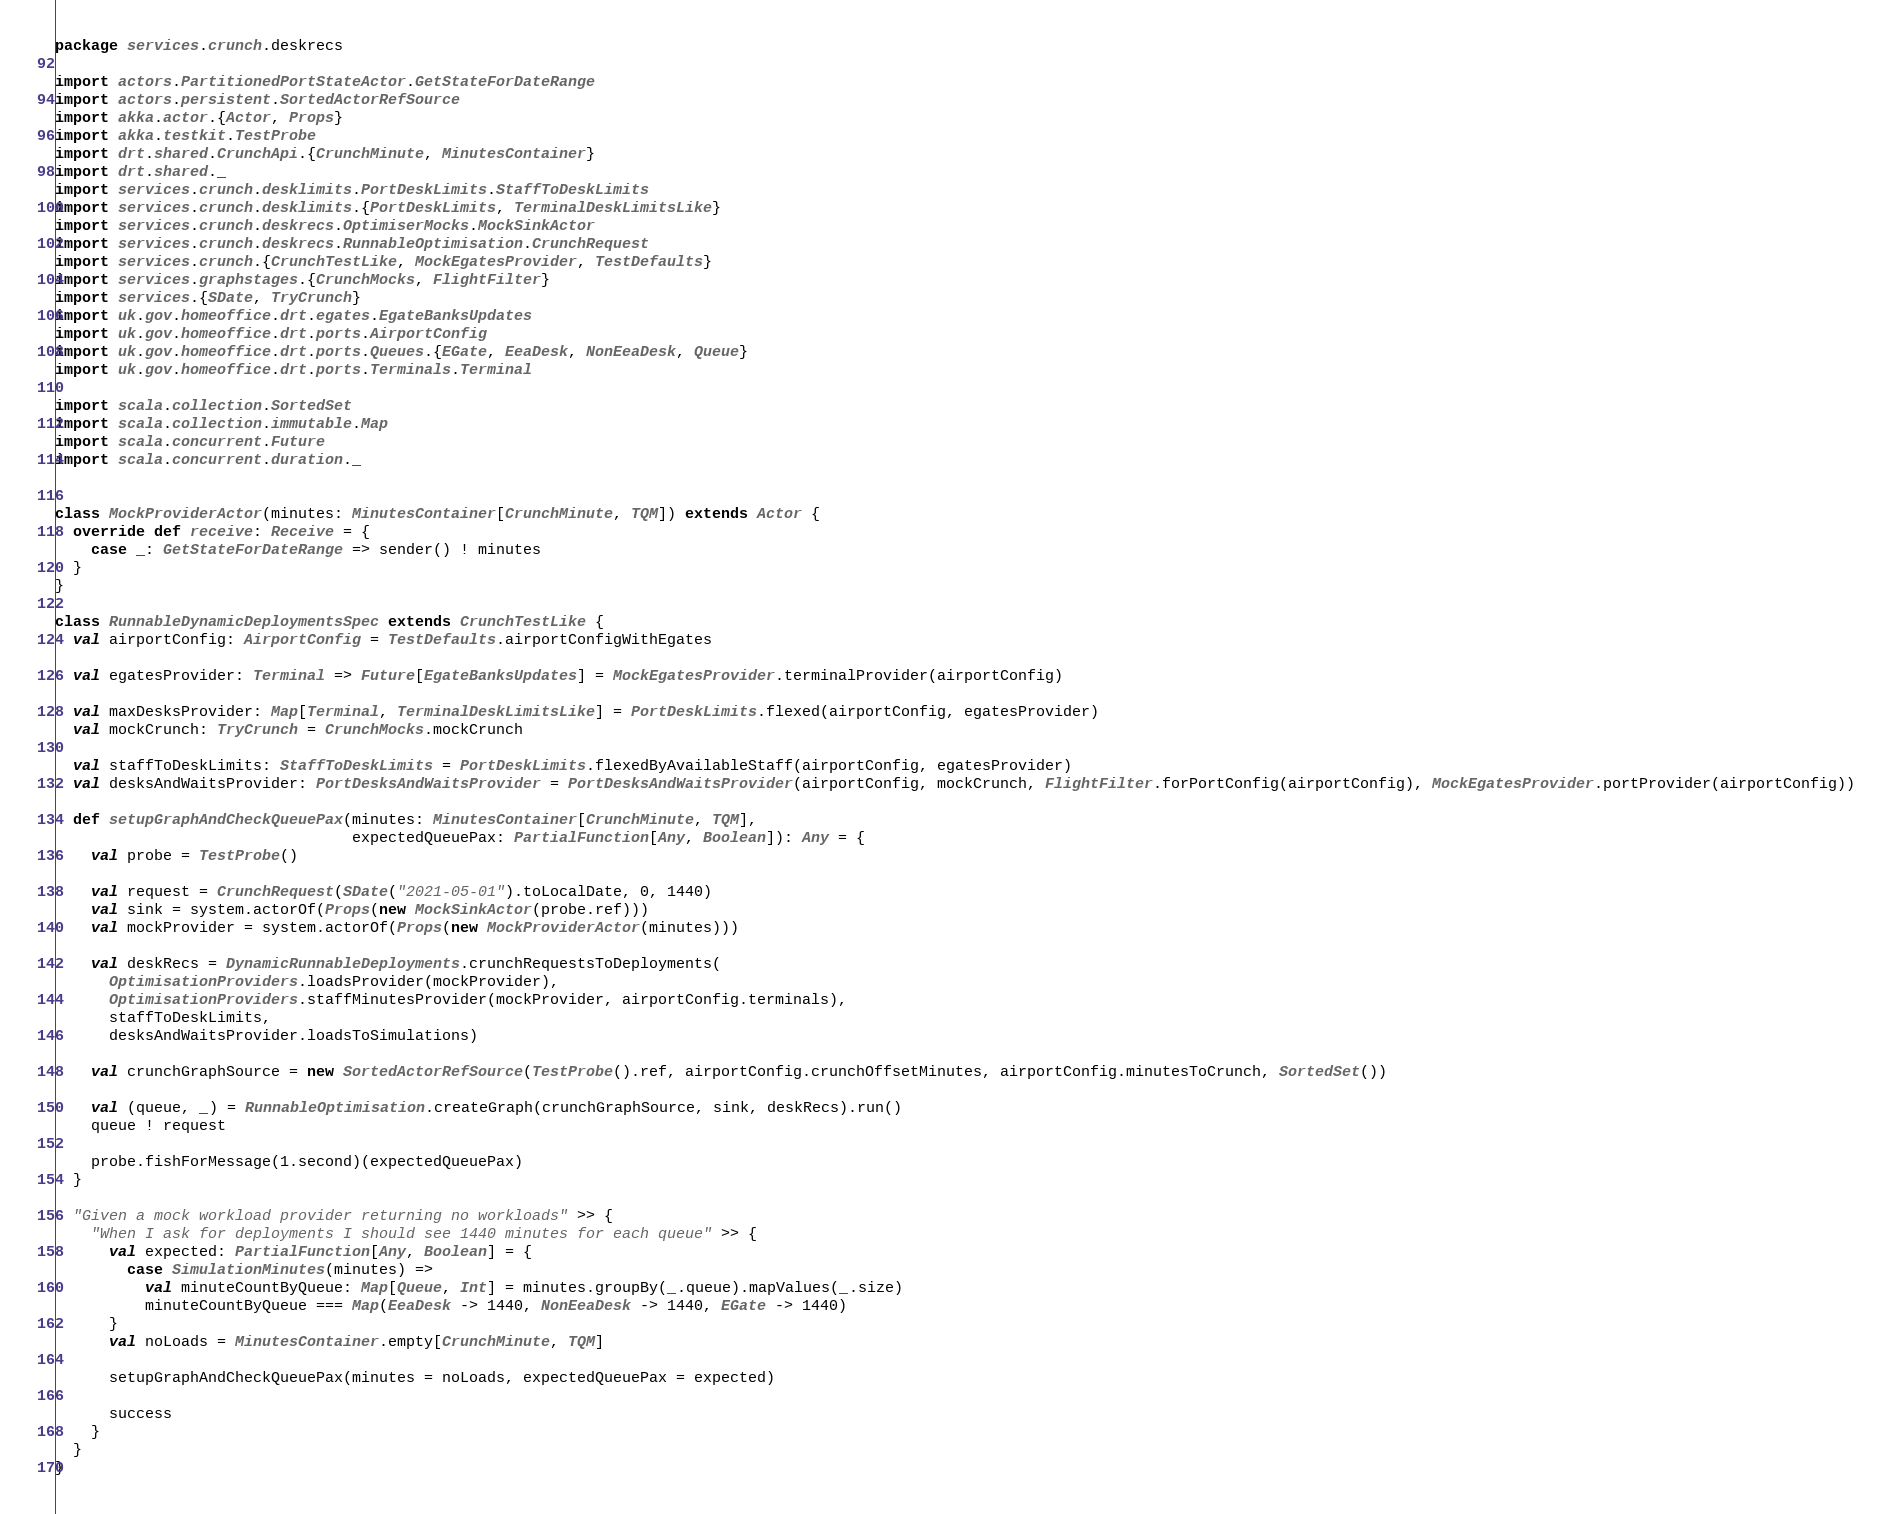Convert code to text. <code><loc_0><loc_0><loc_500><loc_500><_Scala_>package services.crunch.deskrecs

import actors.PartitionedPortStateActor.GetStateForDateRange
import actors.persistent.SortedActorRefSource
import akka.actor.{Actor, Props}
import akka.testkit.TestProbe
import drt.shared.CrunchApi.{CrunchMinute, MinutesContainer}
import drt.shared._
import services.crunch.desklimits.PortDeskLimits.StaffToDeskLimits
import services.crunch.desklimits.{PortDeskLimits, TerminalDeskLimitsLike}
import services.crunch.deskrecs.OptimiserMocks.MockSinkActor
import services.crunch.deskrecs.RunnableOptimisation.CrunchRequest
import services.crunch.{CrunchTestLike, MockEgatesProvider, TestDefaults}
import services.graphstages.{CrunchMocks, FlightFilter}
import services.{SDate, TryCrunch}
import uk.gov.homeoffice.drt.egates.EgateBanksUpdates
import uk.gov.homeoffice.drt.ports.AirportConfig
import uk.gov.homeoffice.drt.ports.Queues.{EGate, EeaDesk, NonEeaDesk, Queue}
import uk.gov.homeoffice.drt.ports.Terminals.Terminal

import scala.collection.SortedSet
import scala.collection.immutable.Map
import scala.concurrent.Future
import scala.concurrent.duration._


class MockProviderActor(minutes: MinutesContainer[CrunchMinute, TQM]) extends Actor {
  override def receive: Receive = {
    case _: GetStateForDateRange => sender() ! minutes
  }
}

class RunnableDynamicDeploymentsSpec extends CrunchTestLike {
  val airportConfig: AirportConfig = TestDefaults.airportConfigWithEgates

  val egatesProvider: Terminal => Future[EgateBanksUpdates] = MockEgatesProvider.terminalProvider(airportConfig)

  val maxDesksProvider: Map[Terminal, TerminalDeskLimitsLike] = PortDeskLimits.flexed(airportConfig, egatesProvider)
  val mockCrunch: TryCrunch = CrunchMocks.mockCrunch

  val staffToDeskLimits: StaffToDeskLimits = PortDeskLimits.flexedByAvailableStaff(airportConfig, egatesProvider)
  val desksAndWaitsProvider: PortDesksAndWaitsProvider = PortDesksAndWaitsProvider(airportConfig, mockCrunch, FlightFilter.forPortConfig(airportConfig), MockEgatesProvider.portProvider(airportConfig))

  def setupGraphAndCheckQueuePax(minutes: MinutesContainer[CrunchMinute, TQM],
                                 expectedQueuePax: PartialFunction[Any, Boolean]): Any = {
    val probe = TestProbe()

    val request = CrunchRequest(SDate("2021-05-01").toLocalDate, 0, 1440)
    val sink = system.actorOf(Props(new MockSinkActor(probe.ref)))
    val mockProvider = system.actorOf(Props(new MockProviderActor(minutes)))

    val deskRecs = DynamicRunnableDeployments.crunchRequestsToDeployments(
      OptimisationProviders.loadsProvider(mockProvider),
      OptimisationProviders.staffMinutesProvider(mockProvider, airportConfig.terminals),
      staffToDeskLimits,
      desksAndWaitsProvider.loadsToSimulations)

    val crunchGraphSource = new SortedActorRefSource(TestProbe().ref, airportConfig.crunchOffsetMinutes, airportConfig.minutesToCrunch, SortedSet())

    val (queue, _) = RunnableOptimisation.createGraph(crunchGraphSource, sink, deskRecs).run()
    queue ! request

    probe.fishForMessage(1.second)(expectedQueuePax)
  }

  "Given a mock workload provider returning no workloads" >> {
    "When I ask for deployments I should see 1440 minutes for each queue" >> {
      val expected: PartialFunction[Any, Boolean] = {
        case SimulationMinutes(minutes) =>
          val minuteCountByQueue: Map[Queue, Int] = minutes.groupBy(_.queue).mapValues(_.size)
          minuteCountByQueue === Map(EeaDesk -> 1440, NonEeaDesk -> 1440, EGate -> 1440)
      }
      val noLoads = MinutesContainer.empty[CrunchMinute, TQM]

      setupGraphAndCheckQueuePax(minutes = noLoads, expectedQueuePax = expected)

      success
    }
  }
}
</code> 